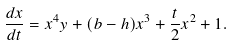<formula> <loc_0><loc_0><loc_500><loc_500>\frac { d x } { d t } = x ^ { 4 } y + ( b - h ) x ^ { 3 } + \frac { t } { 2 } x ^ { 2 } + 1 .</formula> 